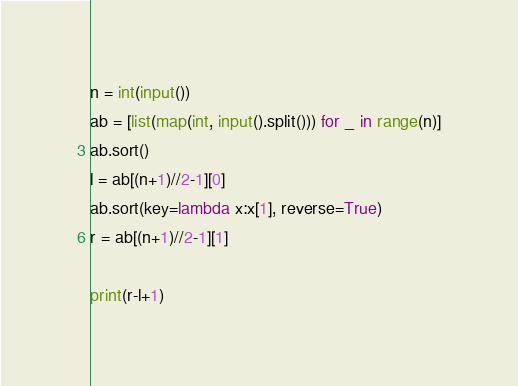Convert code to text. <code><loc_0><loc_0><loc_500><loc_500><_Python_>n = int(input())
ab = [list(map(int, input().split())) for _ in range(n)]
ab.sort()
l = ab[(n+1)//2-1][0]
ab.sort(key=lambda x:x[1], reverse=True)
r = ab[(n+1)//2-1][1]

print(r-l+1)</code> 